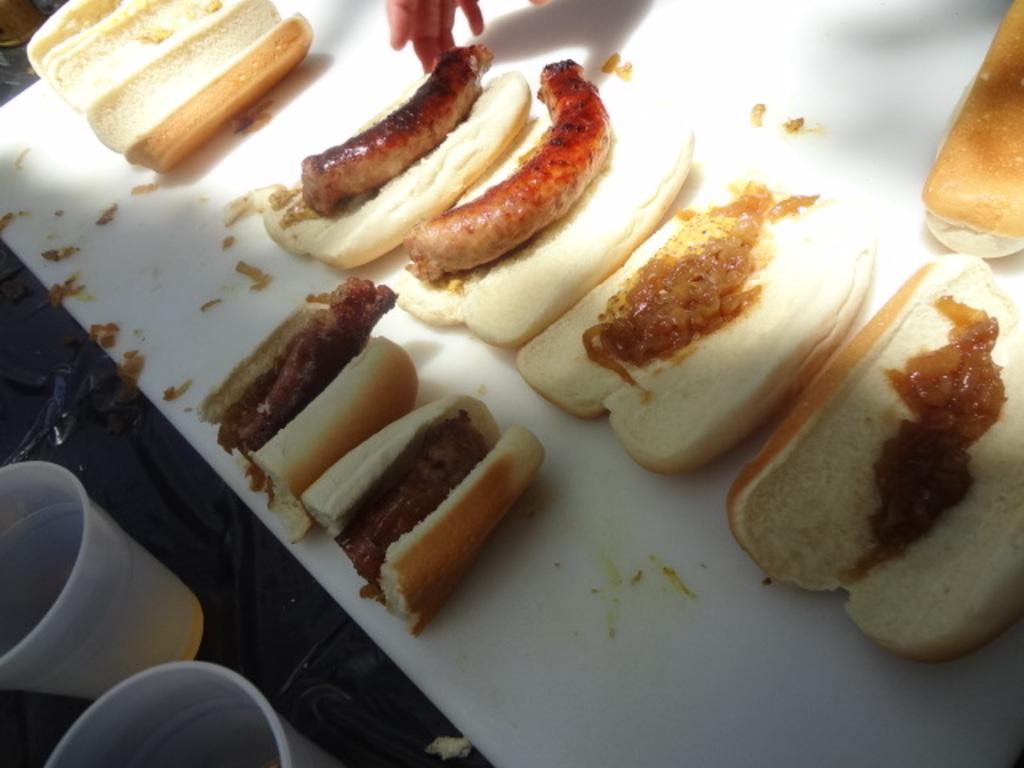What type of food is arranged on the white sheet in the image? There are hot dogs arranged on a white sheet in the image. What other items can be seen on the table? There are two glasses on the table. Can you describe the position of the person's hand in the image? A person's hand is near the hot dogs and glasses in the image. How many sisters are present in the image? There is no mention of sisters in the image, so we cannot determine their presence. 